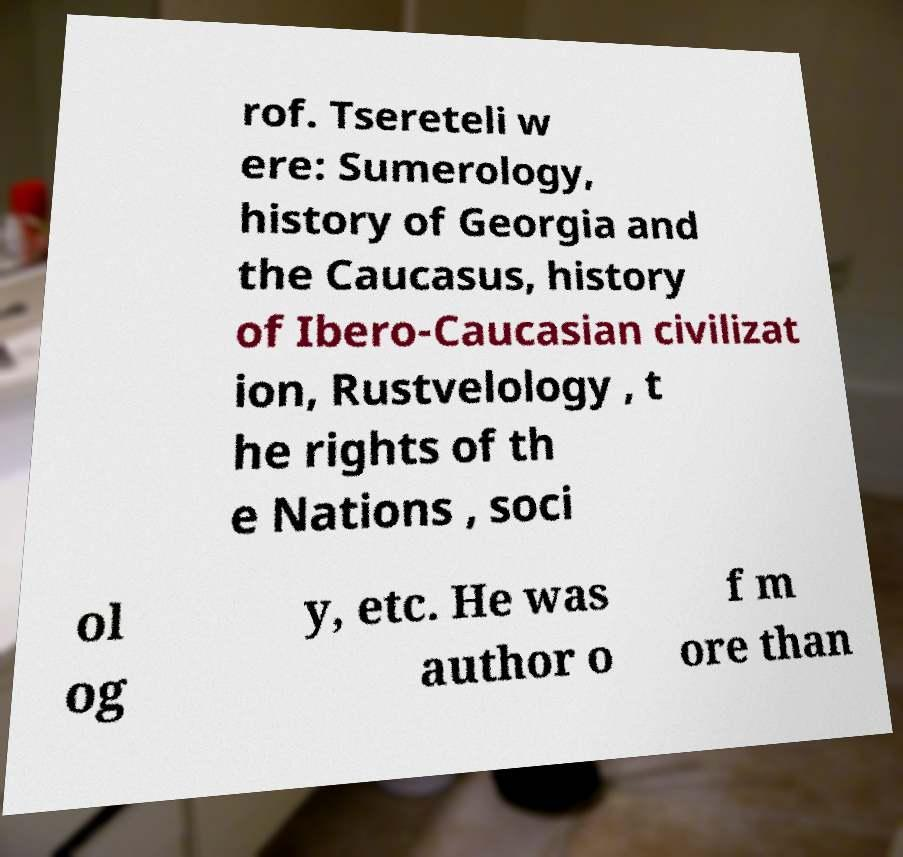Can you read and provide the text displayed in the image?This photo seems to have some interesting text. Can you extract and type it out for me? rof. Tsereteli w ere: Sumerology, history of Georgia and the Caucasus, history of Ibero-Caucasian civilizat ion, Rustvelology , t he rights of th e Nations , soci ol og y, etc. He was author o f m ore than 